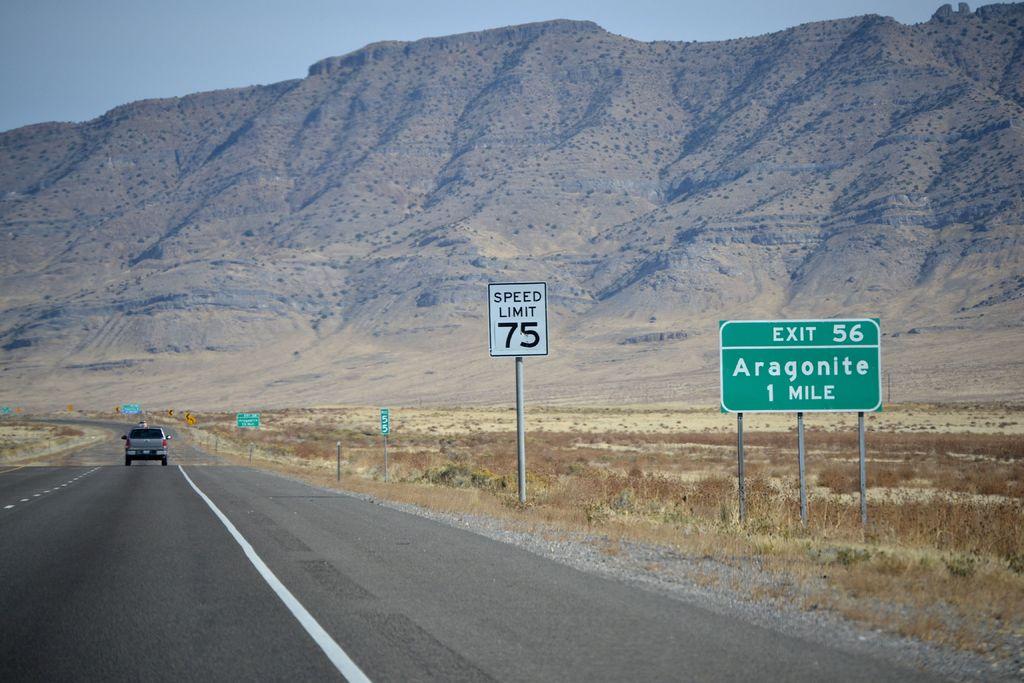How far is exit 56?
Your answer should be very brief. 1 mile. What is the speed limit?
Keep it short and to the point. 75. 